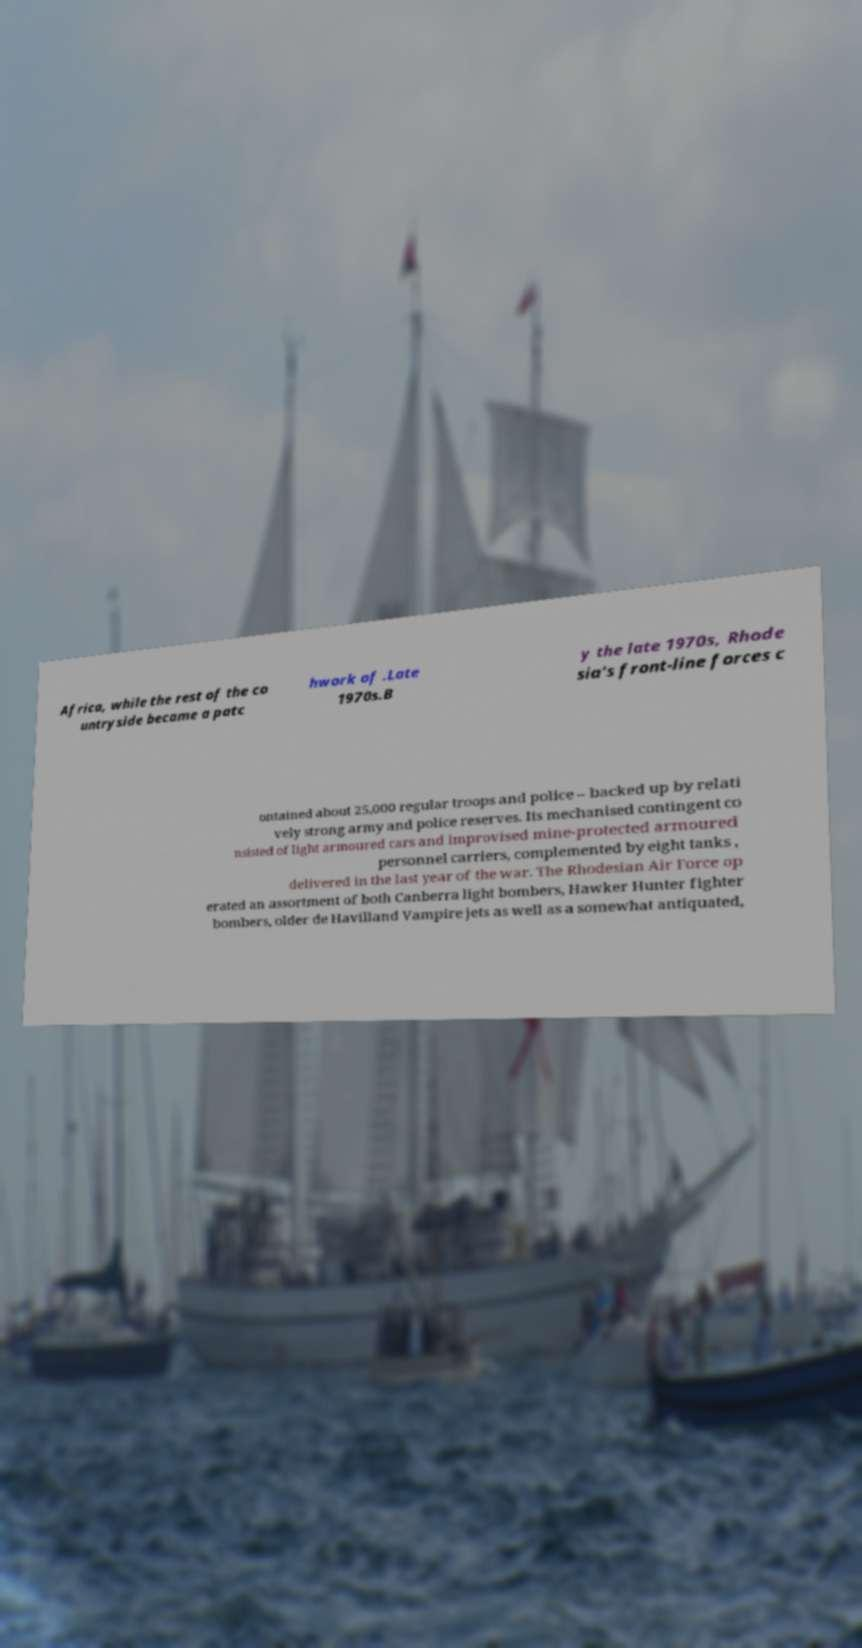Could you assist in decoding the text presented in this image and type it out clearly? Africa, while the rest of the co untryside became a patc hwork of .Late 1970s.B y the late 1970s, Rhode sia's front-line forces c ontained about 25,000 regular troops and police – backed up by relati vely strong army and police reserves. Its mechanised contingent co nsisted of light armoured cars and improvised mine-protected armoured personnel carriers, complemented by eight tanks , delivered in the last year of the war. The Rhodesian Air Force op erated an assortment of both Canberra light bombers, Hawker Hunter fighter bombers, older de Havilland Vampire jets as well as a somewhat antiquated, 